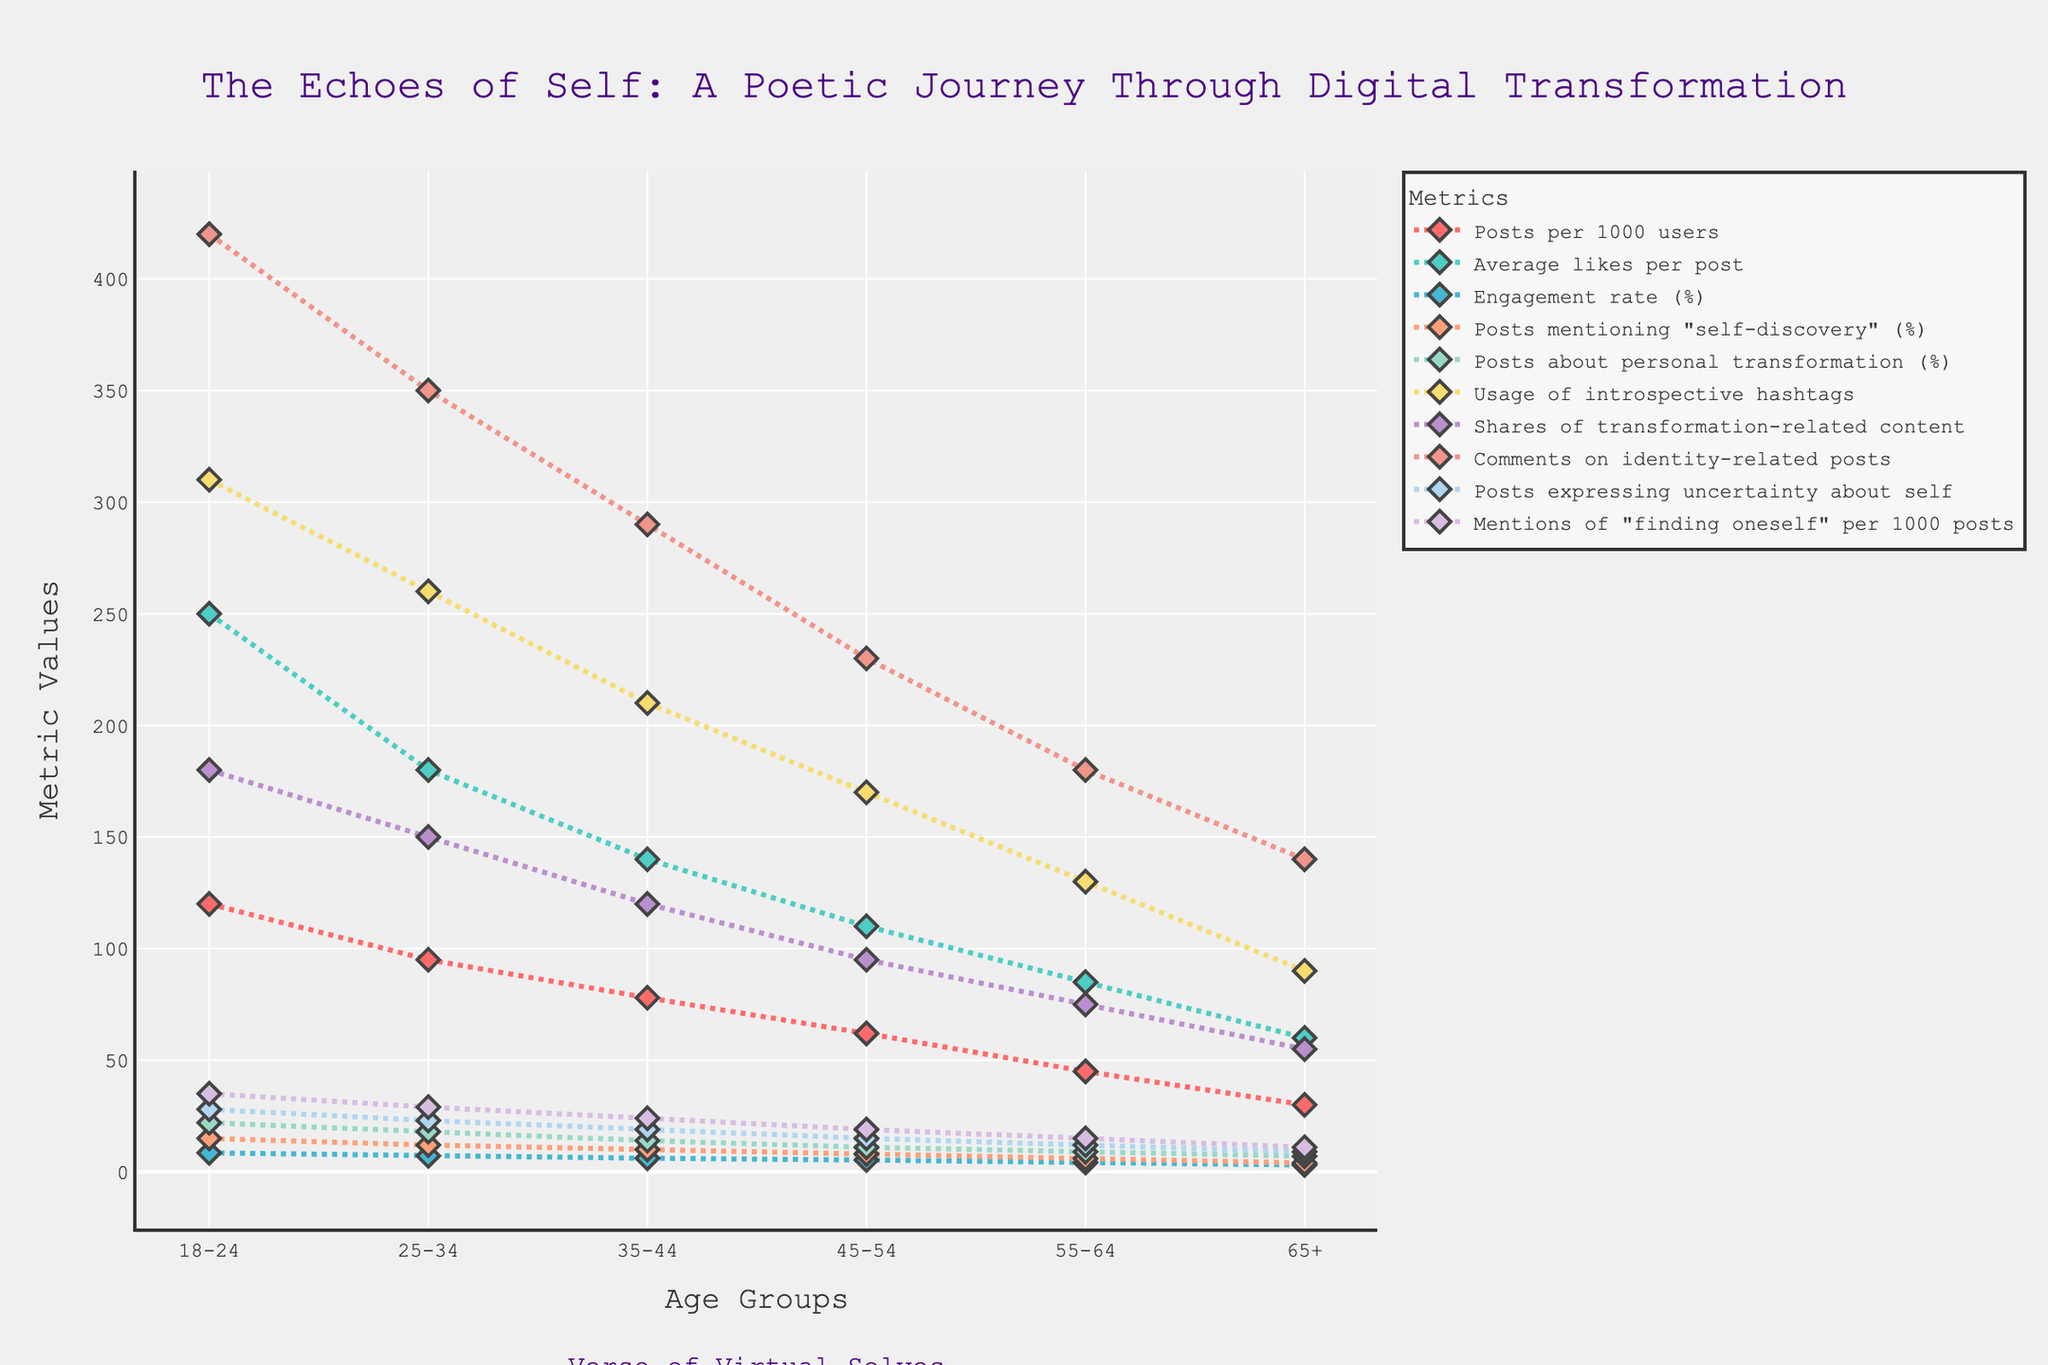What age group has the highest engagement rate (%)? By observing the line that represents engagement rate on the graph, locate the highest point and identify which age group it corresponds to.
Answer: 18-24 Which metric shows the largest decrease from the 18-24 age group to the 65+ age group? Compare the differences between 18-24 and 65+ values across all metrics. The metric with the largest difference is the answer.
Answer: Usage of introspective hashtags What is the sum of posts mentioning "self-discovery" (%) for the age groups 25-34 and 35-44? Add the values of posts mentioning "self-discovery" (%) for age groups 25-34 and 35-44. So, 12 + 10.
Answer: 22 Which metric has the smallest difference between the 45-54 and 55-64 age groups? Calculate the difference between the 45-54 and 55-64 age groups for each metric, and identify the smallest difference.
Answer: Posts expressing uncertainty about self How does the engagement rate (%) trend as the age group increases? Look at the trend of the line representing engagement rate (%) from left (youngest age group) to right (oldest age group).
Answer: Decreases What is the average number of comments on identity-related posts across all age groups? Sum the values of comments on identity-related posts for all age groups and divide by the number of age groups (420 + 350 + 290 + 230 + 180 + 140) / 6.
Answer: 268.33 Which two age groups have the closest value in "posts about personal transformation (%)"? Compare each age group's values for "posts about personal transformation (%)" and find the two with the smallest difference (11 and 9 for 45-54 and 55-64).
Answer: 45-54 and 55-64 By how much do average likes per post differ between the 25-34 and 35-44 age groups? Subtract the value of average likes per post for 35-44 age group from the 25-34 age group (180 - 140).
Answer: 40 Is there any metric where the 35-44 age group has a higher value than all older age groups? Check all metrics values for the 35-44 age group and see if any value is higher than those for age groups 45-54, 55-64, and 65+.
Answer: Yes, comments on identity-related posts Which age group has the lowest value for "posts per 1000 users"? Locate the lowest point on the line representing "posts per 1000 users" and identify its corresponding age group.
Answer: 65+ 